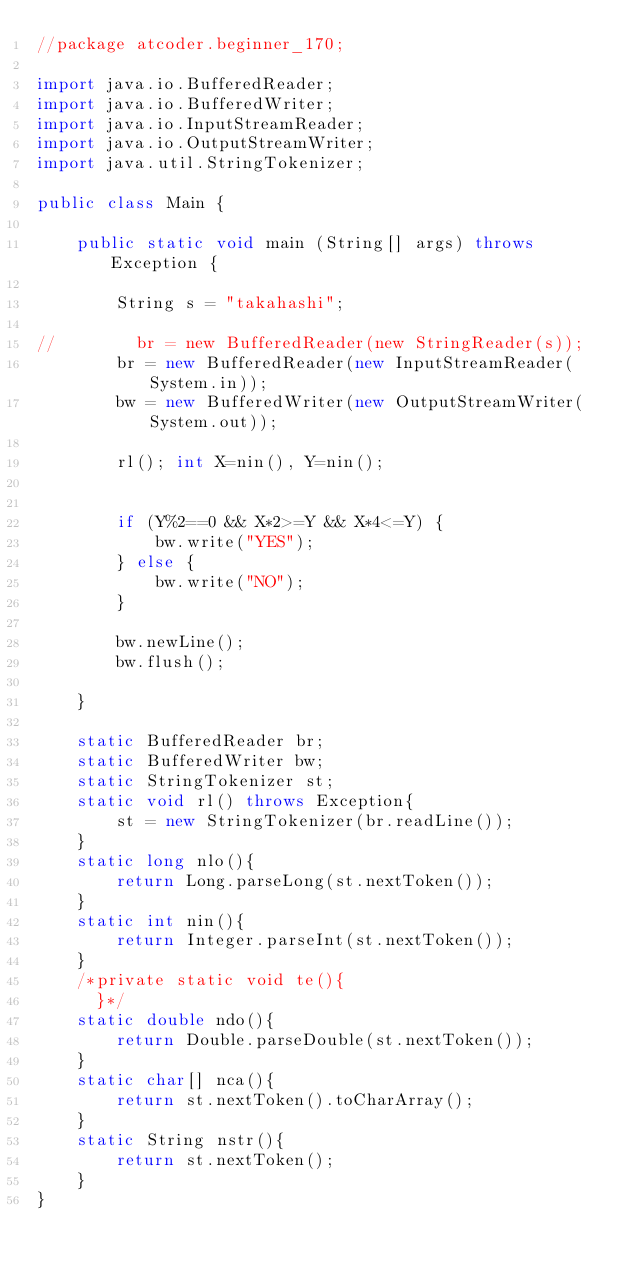<code> <loc_0><loc_0><loc_500><loc_500><_Java_>//package atcoder.beginner_170;

import java.io.BufferedReader;
import java.io.BufferedWriter;
import java.io.InputStreamReader;
import java.io.OutputStreamWriter;
import java.util.StringTokenizer;

public class Main {

    public static void main (String[] args) throws Exception {

        String s = "takahashi";

//        br = new BufferedReader(new StringReader(s));
        br = new BufferedReader(new InputStreamReader(System.in));
        bw = new BufferedWriter(new OutputStreamWriter(System.out));

        rl(); int X=nin(), Y=nin();
        
        
        if (Y%2==0 && X*2>=Y && X*4<=Y) {
            bw.write("YES");
        } else {
            bw.write("NO");
        }
        
        bw.newLine();
        bw.flush();

    }

    static BufferedReader br;
    static BufferedWriter bw;
    static StringTokenizer st;
    static void rl() throws Exception{
        st = new StringTokenizer(br.readLine());
    }
    static long nlo(){
        return Long.parseLong(st.nextToken());
    }
    static int nin(){
        return Integer.parseInt(st.nextToken());
    }
    /*private static void te(){
      }*/
    static double ndo(){
        return Double.parseDouble(st.nextToken());
    }
    static char[] nca(){
        return st.nextToken().toCharArray();
    }
    static String nstr(){
        return st.nextToken();
    }
}</code> 